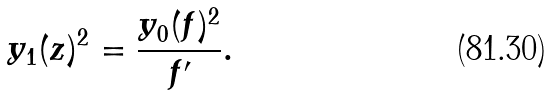Convert formula to latex. <formula><loc_0><loc_0><loc_500><loc_500>y _ { 1 } ( z ) ^ { 2 } = \frac { y _ { 0 } ( f ) ^ { 2 } } { f ^ { \prime } } .</formula> 